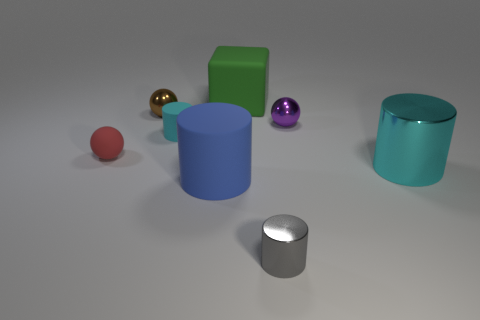How many blue rubber spheres are there?
Provide a short and direct response. 0. How many tiny rubber cylinders have the same color as the large block?
Your response must be concise. 0. Is the shape of the large matte thing behind the red matte ball the same as the shiny object that is in front of the blue cylinder?
Ensure brevity in your answer.  No. What is the color of the ball that is to the right of the object in front of the rubber thing that is in front of the red matte sphere?
Keep it short and to the point. Purple. What is the color of the small metal object that is in front of the small purple metallic sphere?
Give a very brief answer. Gray. There is another cylinder that is the same size as the blue rubber cylinder; what is its color?
Your answer should be compact. Cyan. Do the blue thing and the matte cube have the same size?
Give a very brief answer. Yes. There is a purple ball; what number of big matte cylinders are right of it?
Provide a short and direct response. 0. What number of objects are either tiny things that are on the left side of the small cyan rubber cylinder or small purple metallic things?
Your response must be concise. 3. Is the number of large blue matte things on the left side of the tiny red thing greater than the number of large cyan cylinders behind the cyan shiny cylinder?
Your answer should be compact. No. 